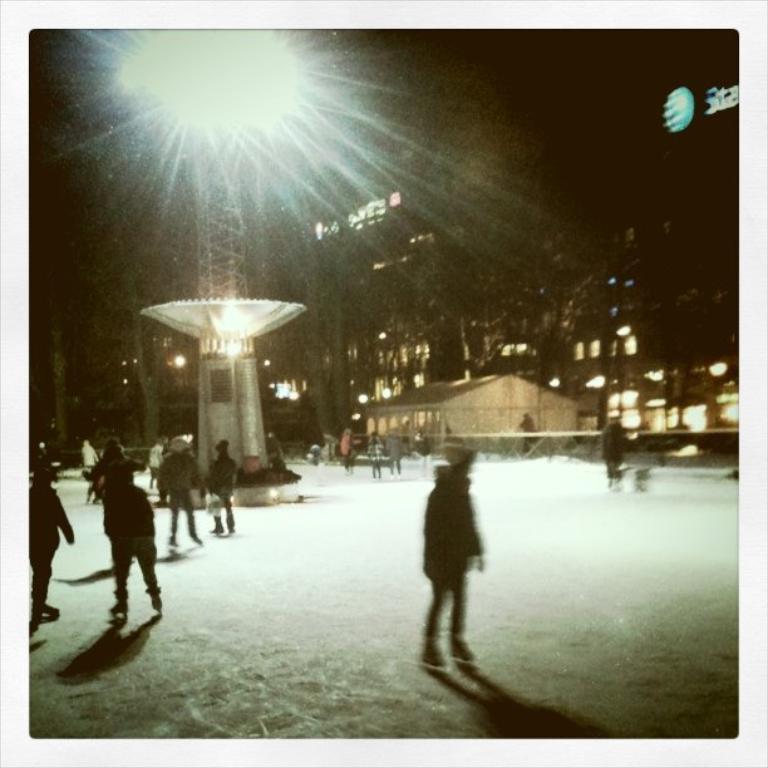Can you describe this image briefly? In this picture we can observe some people standing on the ground. We can observe a tower to which a light was fixed. We can observe some trees and a building. In the background it is completely dark. 